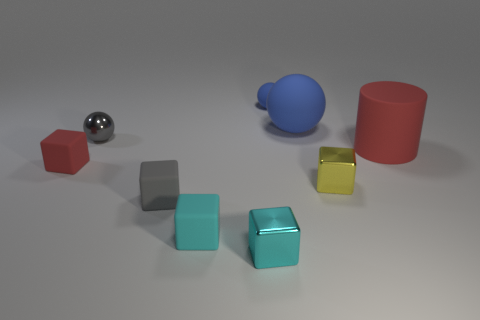Subtract all yellow blocks. How many blocks are left? 4 Subtract all gray rubber blocks. How many blocks are left? 4 Subtract all green cubes. Subtract all brown cylinders. How many cubes are left? 5 Add 1 small metal balls. How many objects exist? 10 Subtract all blocks. How many objects are left? 4 Add 9 shiny spheres. How many shiny spheres exist? 10 Subtract 0 green spheres. How many objects are left? 9 Subtract all tiny blue shiny cylinders. Subtract all small gray shiny objects. How many objects are left? 8 Add 5 tiny red matte cubes. How many tiny red matte cubes are left? 6 